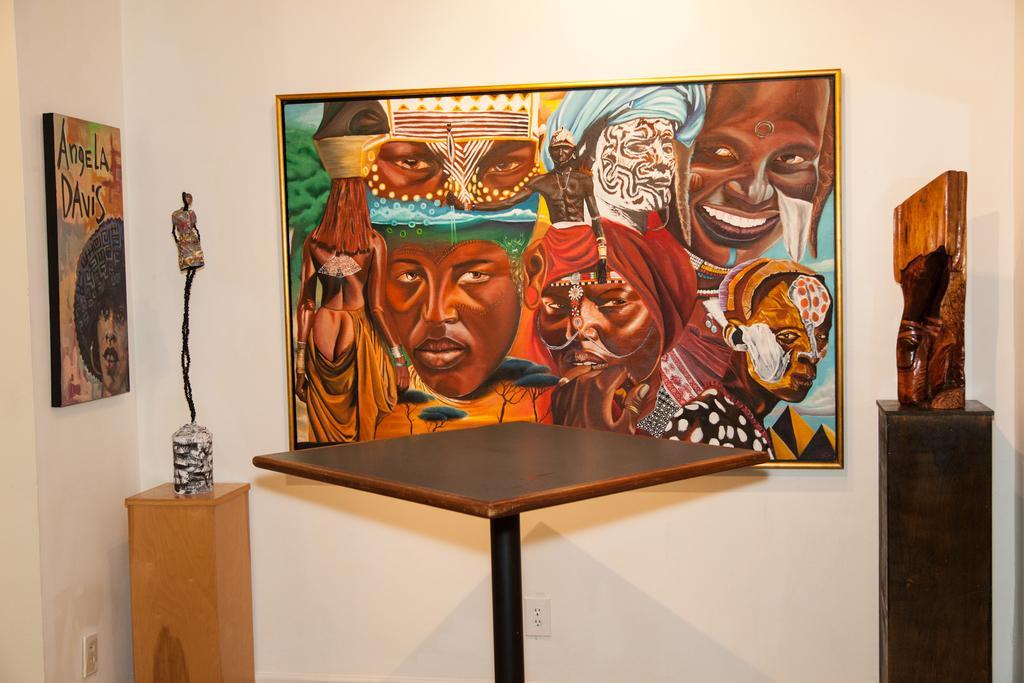Can you describe this image briefly? In this image we can see a table stand, objects on a wooden stand and paining boards on the walls. 